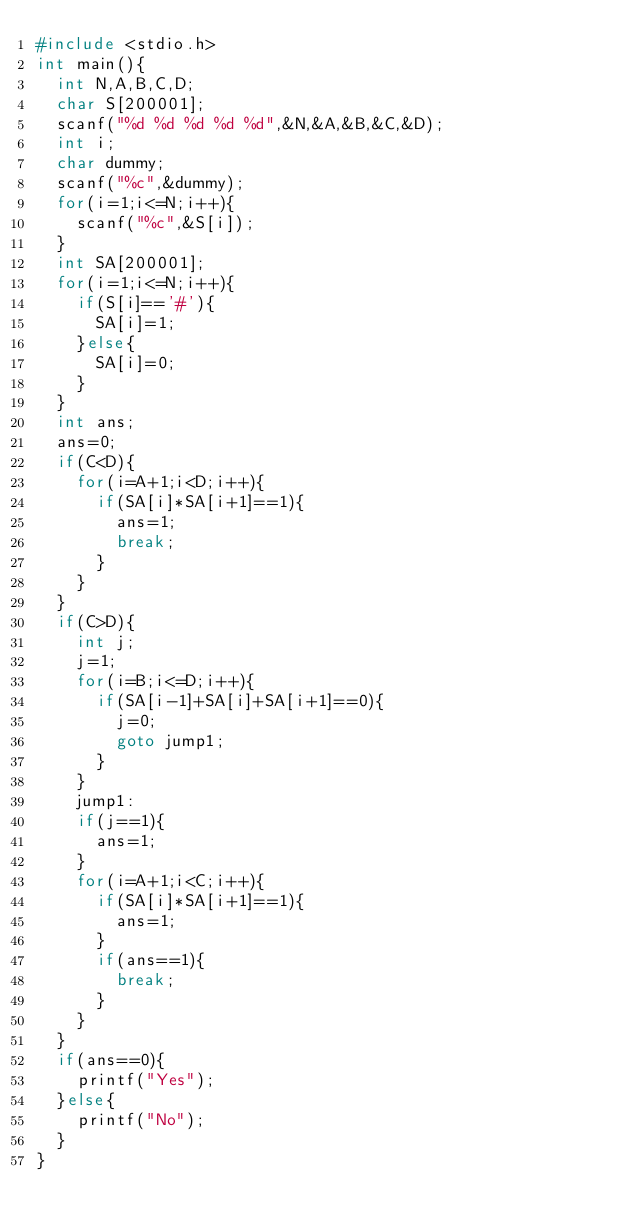Convert code to text. <code><loc_0><loc_0><loc_500><loc_500><_C_>#include <stdio.h>
int main(){
	int N,A,B,C,D;
	char S[200001];
	scanf("%d %d %d %d %d",&N,&A,&B,&C,&D);
	int i;
	char dummy;
	scanf("%c",&dummy);
	for(i=1;i<=N;i++){
		scanf("%c",&S[i]);
	}
	int SA[200001];
	for(i=1;i<=N;i++){
		if(S[i]=='#'){
			SA[i]=1;
		}else{
			SA[i]=0;
		}
	}
	int ans;
	ans=0;
	if(C<D){
		for(i=A+1;i<D;i++){
			if(SA[i]*SA[i+1]==1){
				ans=1;
				break;
			}
		}
	}
	if(C>D){
		int j;
		j=1;
		for(i=B;i<=D;i++){
			if(SA[i-1]+SA[i]+SA[i+1]==0){
				j=0;
				goto jump1;
			}
		}
		jump1:
		if(j==1){
			ans=1;
		}
		for(i=A+1;i<C;i++){
			if(SA[i]*SA[i+1]==1){
				ans=1;
			}
			if(ans==1){
				break;
			}
		}
	}
	if(ans==0){
		printf("Yes");
	}else{
		printf("No");
	}
}
</code> 